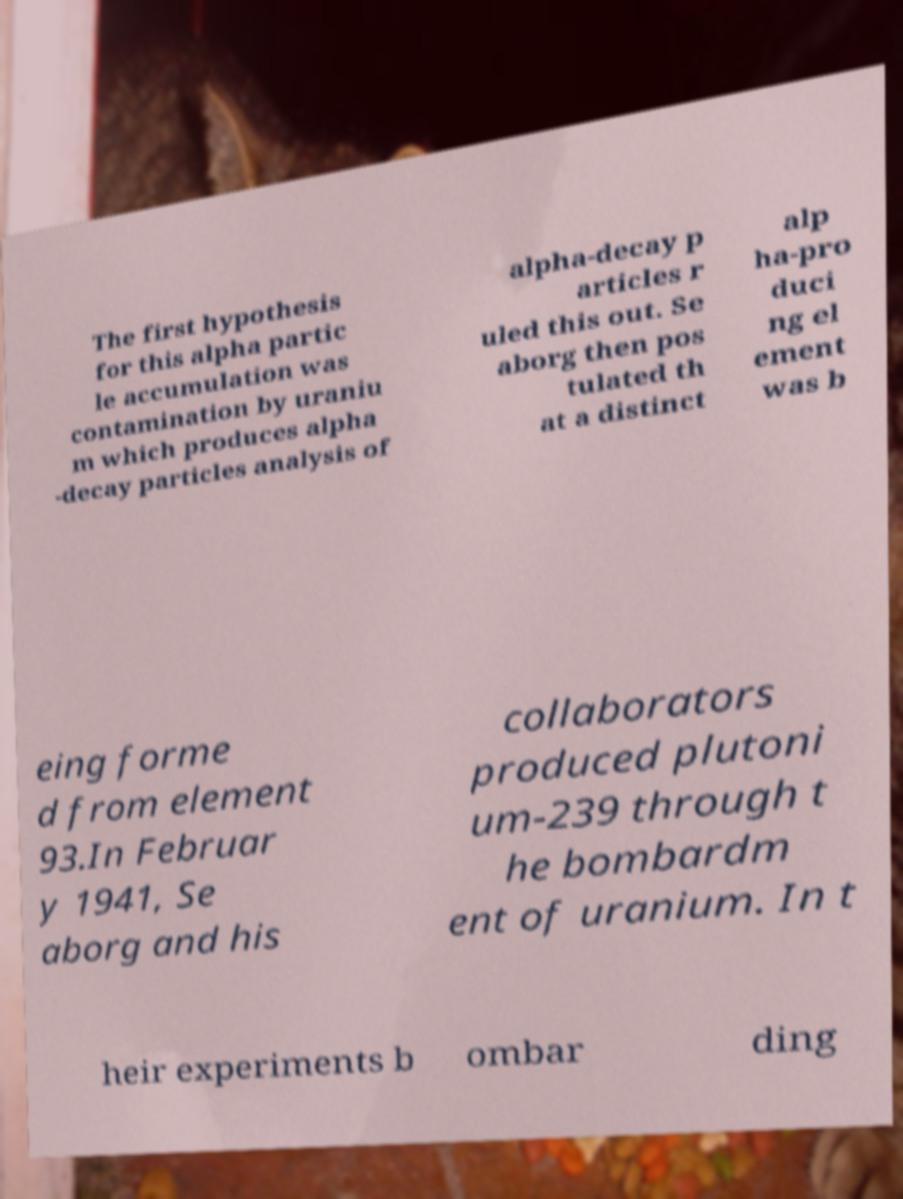Please read and relay the text visible in this image. What does it say? The first hypothesis for this alpha partic le accumulation was contamination by uraniu m which produces alpha -decay particles analysis of alpha-decay p articles r uled this out. Se aborg then pos tulated th at a distinct alp ha-pro duci ng el ement was b eing forme d from element 93.In Februar y 1941, Se aborg and his collaborators produced plutoni um-239 through t he bombardm ent of uranium. In t heir experiments b ombar ding 